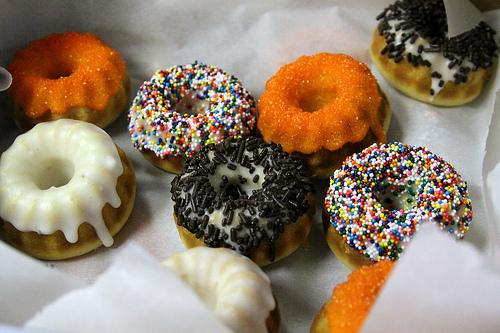How many donuts are on the white bakery paper? There are several donuts on the white bakery paper. Mention two distinct features of the donut with white frosting. The donut with white frosting has frozen drips over its side, and it is covered in black sprinkles. Identify the types of doughnut frostings present in the image. The donuts have white, orange, and chocolate frostings with different types of sprinkles. Provide a brief description of the primary objects in the image. There are various small colorful donuts with different toppings, such as white, orange, and chocolate frostings, and different kinds of sprinkles, all placed on white bakery paper. Explain the texture of one particular doughnut in the image. The doughnut with exposed ridges has a semi-circular shape and a distinct rough texture. What type of paper are the donuts placed on, and what is its color? The donuts are placed on a parchment paper, which is white in color. Describe the appearance of the hole in the middle of the doughnut with orange and yellow frosting. The hole in the middle of the orange and yellow doughnut is covered with icing and black sprinkles. What are the specific colors of the small sprinkles on one of the doughnuts? The small sprinkles on one of the doughnuts are different colors, including round, hard, and sparkly varieties. What is special about the sprinkles on one of the doughnuts? One of the doughnuts is covered with many round, colorful sprinkles. What are the various toppings found on the donuts in the image? The toppings include white, orange, and chocolate frostings, rainbow and chocolate sprinkles, confetti and nonpareils. 